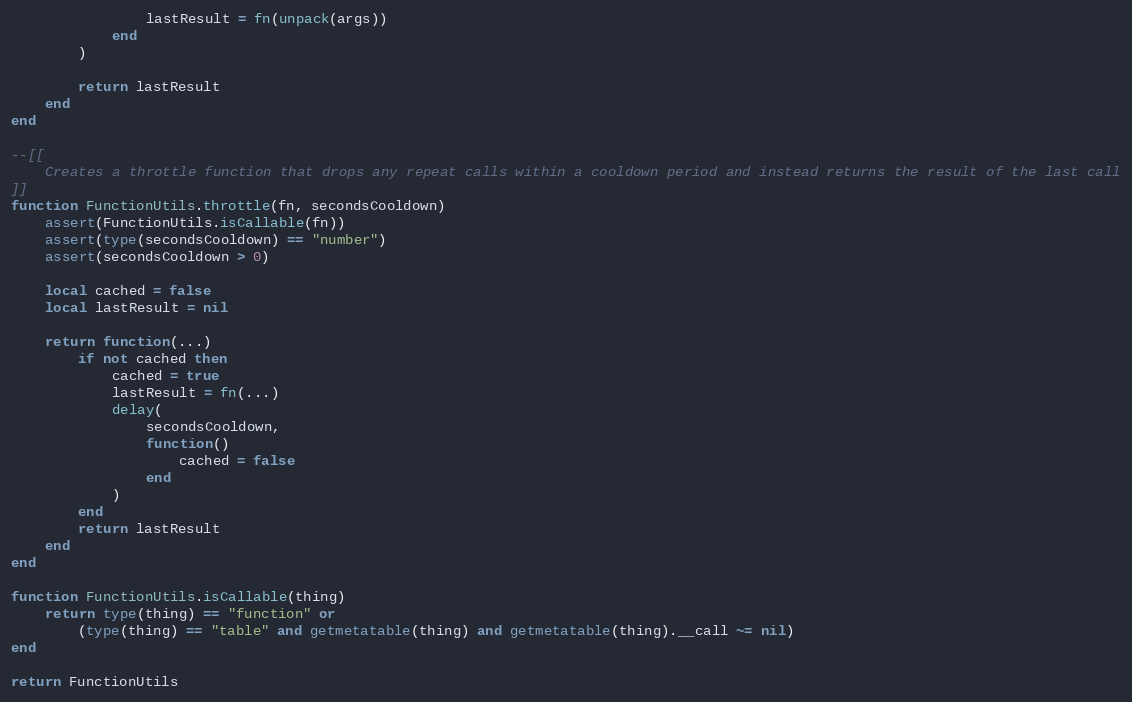Convert code to text. <code><loc_0><loc_0><loc_500><loc_500><_Lua_>				lastResult = fn(unpack(args))
			end
		)

		return lastResult
	end
end

--[[
	Creates a throttle function that drops any repeat calls within a cooldown period and instead returns the result of the last call
]]
function FunctionUtils.throttle(fn, secondsCooldown)
	assert(FunctionUtils.isCallable(fn))
	assert(type(secondsCooldown) == "number")
	assert(secondsCooldown > 0)

	local cached = false
	local lastResult = nil

	return function(...)
		if not cached then
			cached = true
			lastResult = fn(...)
			delay(
				secondsCooldown,
				function()
					cached = false
				end
			)
		end
		return lastResult
	end
end

function FunctionUtils.isCallable(thing)
	return type(thing) == "function" or
		(type(thing) == "table" and getmetatable(thing) and getmetatable(thing).__call ~= nil)
end

return FunctionUtils
</code> 